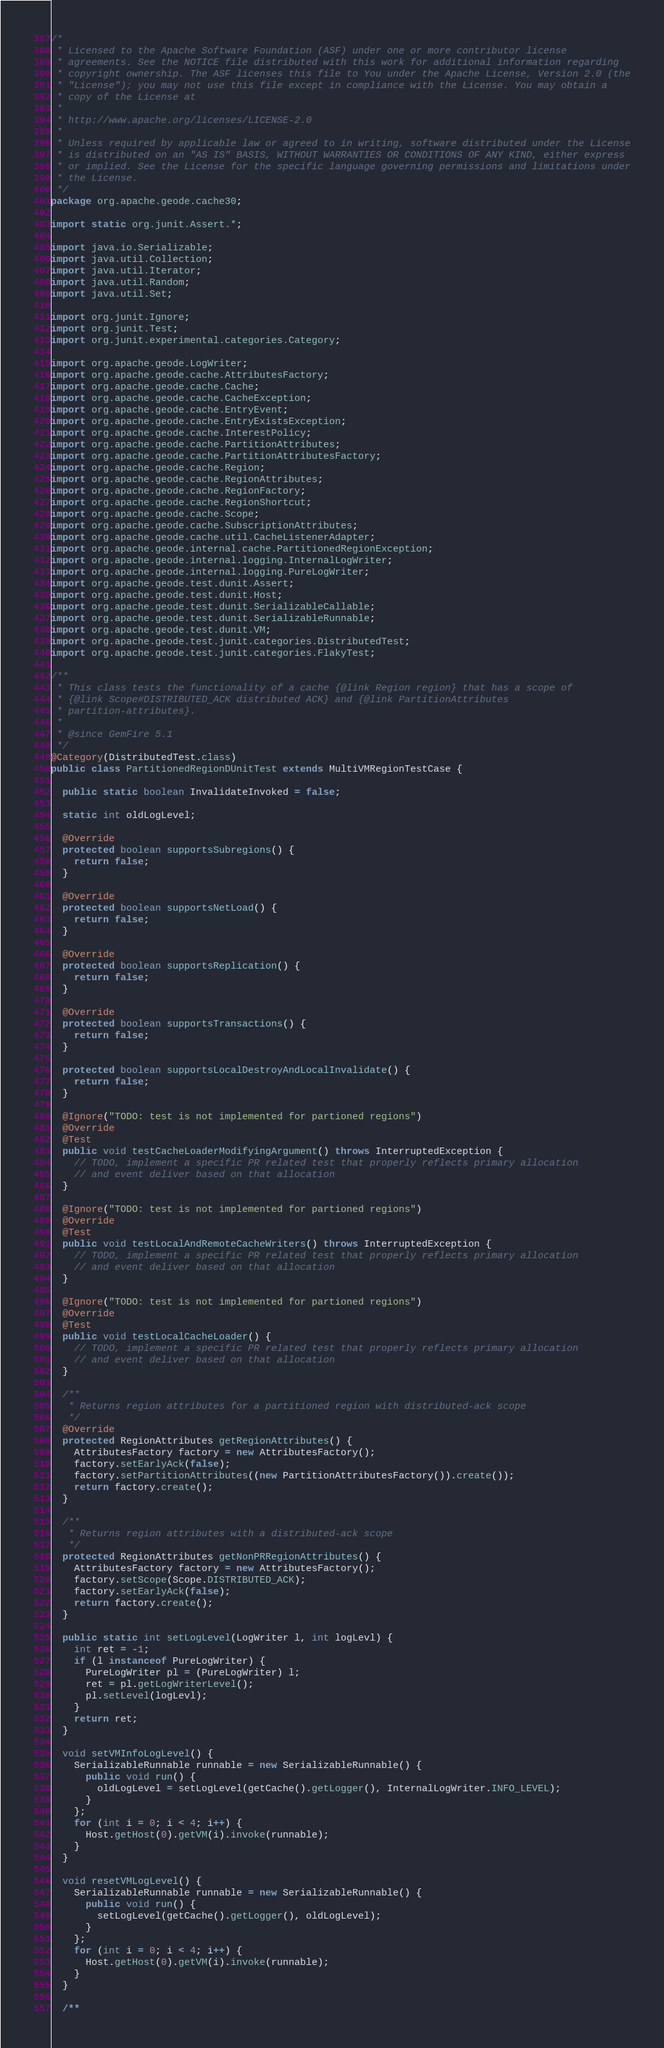Convert code to text. <code><loc_0><loc_0><loc_500><loc_500><_Java_>/*
 * Licensed to the Apache Software Foundation (ASF) under one or more contributor license
 * agreements. See the NOTICE file distributed with this work for additional information regarding
 * copyright ownership. The ASF licenses this file to You under the Apache License, Version 2.0 (the
 * "License"); you may not use this file except in compliance with the License. You may obtain a
 * copy of the License at
 *
 * http://www.apache.org/licenses/LICENSE-2.0
 *
 * Unless required by applicable law or agreed to in writing, software distributed under the License
 * is distributed on an "AS IS" BASIS, WITHOUT WARRANTIES OR CONDITIONS OF ANY KIND, either express
 * or implied. See the License for the specific language governing permissions and limitations under
 * the License.
 */
package org.apache.geode.cache30;

import static org.junit.Assert.*;

import java.io.Serializable;
import java.util.Collection;
import java.util.Iterator;
import java.util.Random;
import java.util.Set;

import org.junit.Ignore;
import org.junit.Test;
import org.junit.experimental.categories.Category;

import org.apache.geode.LogWriter;
import org.apache.geode.cache.AttributesFactory;
import org.apache.geode.cache.Cache;
import org.apache.geode.cache.CacheException;
import org.apache.geode.cache.EntryEvent;
import org.apache.geode.cache.EntryExistsException;
import org.apache.geode.cache.InterestPolicy;
import org.apache.geode.cache.PartitionAttributes;
import org.apache.geode.cache.PartitionAttributesFactory;
import org.apache.geode.cache.Region;
import org.apache.geode.cache.RegionAttributes;
import org.apache.geode.cache.RegionFactory;
import org.apache.geode.cache.RegionShortcut;
import org.apache.geode.cache.Scope;
import org.apache.geode.cache.SubscriptionAttributes;
import org.apache.geode.cache.util.CacheListenerAdapter;
import org.apache.geode.internal.cache.PartitionedRegionException;
import org.apache.geode.internal.logging.InternalLogWriter;
import org.apache.geode.internal.logging.PureLogWriter;
import org.apache.geode.test.dunit.Assert;
import org.apache.geode.test.dunit.Host;
import org.apache.geode.test.dunit.SerializableCallable;
import org.apache.geode.test.dunit.SerializableRunnable;
import org.apache.geode.test.dunit.VM;
import org.apache.geode.test.junit.categories.DistributedTest;
import org.apache.geode.test.junit.categories.FlakyTest;

/**
 * This class tests the functionality of a cache {@link Region region} that has a scope of
 * {@link Scope#DISTRIBUTED_ACK distributed ACK} and {@link PartitionAttributes
 * partition-attributes}.
 *
 * @since GemFire 5.1
 */
@Category(DistributedTest.class)
public class PartitionedRegionDUnitTest extends MultiVMRegionTestCase {

  public static boolean InvalidateInvoked = false;

  static int oldLogLevel;

  @Override
  protected boolean supportsSubregions() {
    return false;
  }

  @Override
  protected boolean supportsNetLoad() {
    return false;
  }

  @Override
  protected boolean supportsReplication() {
    return false;
  }

  @Override
  protected boolean supportsTransactions() {
    return false;
  }

  protected boolean supportsLocalDestroyAndLocalInvalidate() {
    return false;
  }

  @Ignore("TODO: test is not implemented for partioned regions")
  @Override
  @Test
  public void testCacheLoaderModifyingArgument() throws InterruptedException {
    // TODO, implement a specific PR related test that properly reflects primary allocation
    // and event deliver based on that allocation
  }

  @Ignore("TODO: test is not implemented for partioned regions")
  @Override
  @Test
  public void testLocalAndRemoteCacheWriters() throws InterruptedException {
    // TODO, implement a specific PR related test that properly reflects primary allocation
    // and event deliver based on that allocation
  }

  @Ignore("TODO: test is not implemented for partioned regions")
  @Override
  @Test
  public void testLocalCacheLoader() {
    // TODO, implement a specific PR related test that properly reflects primary allocation
    // and event deliver based on that allocation
  }

  /**
   * Returns region attributes for a partitioned region with distributed-ack scope
   */
  @Override
  protected RegionAttributes getRegionAttributes() {
    AttributesFactory factory = new AttributesFactory();
    factory.setEarlyAck(false);
    factory.setPartitionAttributes((new PartitionAttributesFactory()).create());
    return factory.create();
  }

  /**
   * Returns region attributes with a distributed-ack scope
   */
  protected RegionAttributes getNonPRRegionAttributes() {
    AttributesFactory factory = new AttributesFactory();
    factory.setScope(Scope.DISTRIBUTED_ACK);
    factory.setEarlyAck(false);
    return factory.create();
  }

  public static int setLogLevel(LogWriter l, int logLevl) {
    int ret = -1;
    if (l instanceof PureLogWriter) {
      PureLogWriter pl = (PureLogWriter) l;
      ret = pl.getLogWriterLevel();
      pl.setLevel(logLevl);
    }
    return ret;
  }

  void setVMInfoLogLevel() {
    SerializableRunnable runnable = new SerializableRunnable() {
      public void run() {
        oldLogLevel = setLogLevel(getCache().getLogger(), InternalLogWriter.INFO_LEVEL);
      }
    };
    for (int i = 0; i < 4; i++) {
      Host.getHost(0).getVM(i).invoke(runnable);
    }
  }

  void resetVMLogLevel() {
    SerializableRunnable runnable = new SerializableRunnable() {
      public void run() {
        setLogLevel(getCache().getLogger(), oldLogLevel);
      }
    };
    for (int i = 0; i < 4; i++) {
      Host.getHost(0).getVM(i).invoke(runnable);
    }
  }

  /**</code> 